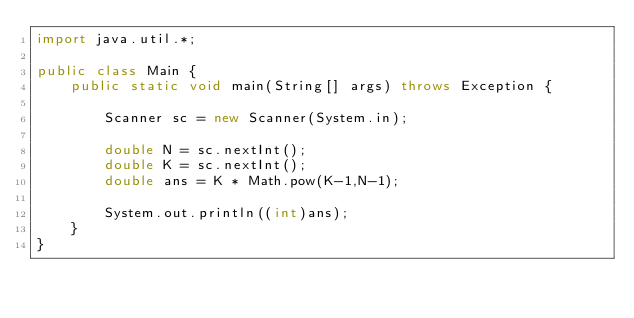Convert code to text. <code><loc_0><loc_0><loc_500><loc_500><_Java_>import java.util.*;

public class Main {
    public static void main(String[] args) throws Exception {

        Scanner sc = new Scanner(System.in);
        
        double N = sc.nextInt();
        double K = sc.nextInt();
        double ans = K * Math.pow(K-1,N-1);
        
        System.out.println((int)ans);
    }
}
</code> 